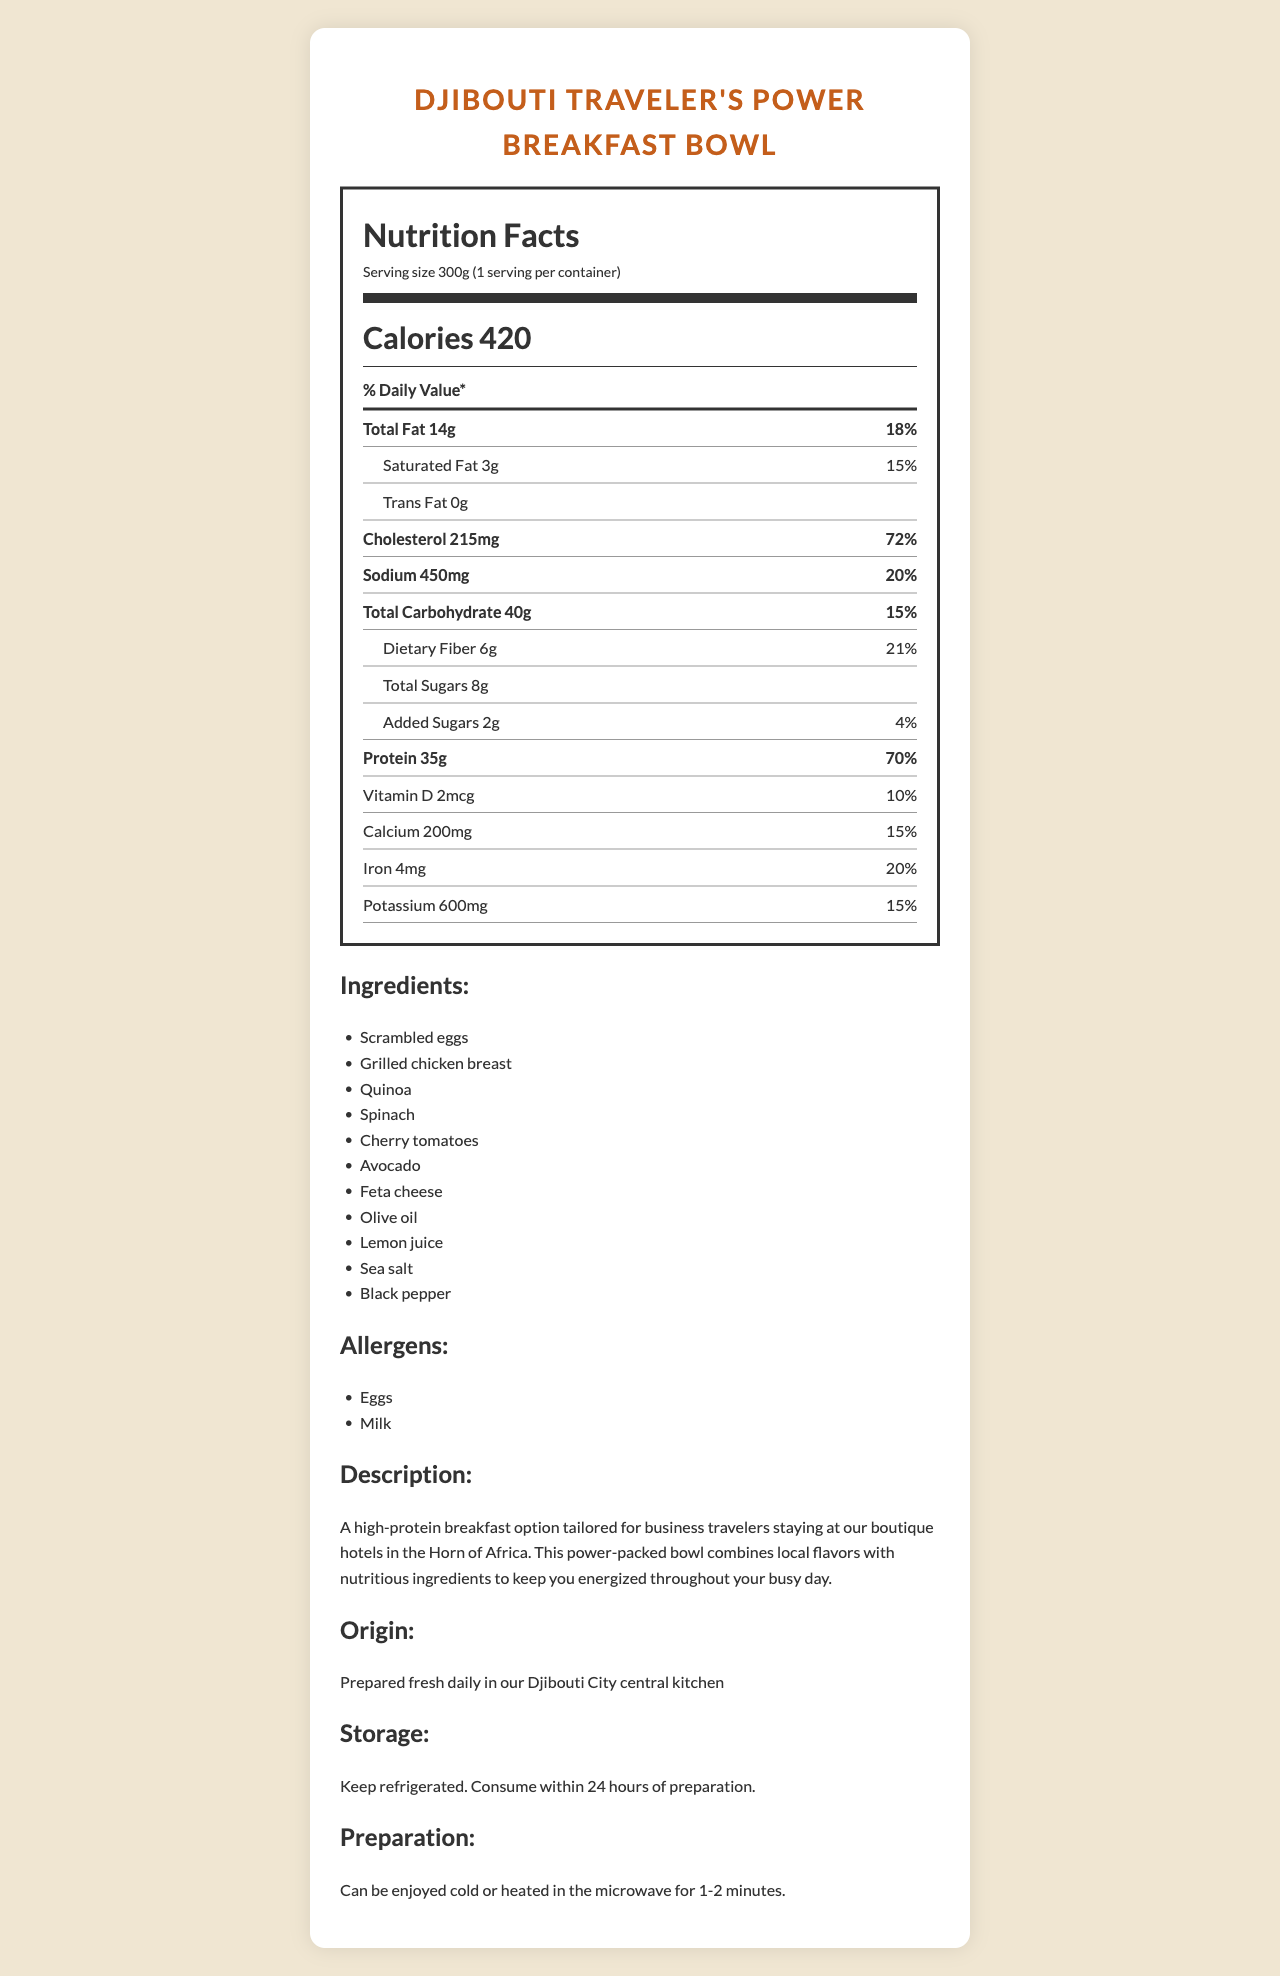what is the serving size of the Djibouti Traveler's Power Breakfast Bowl? The serving size is specified as 300g in the document.
Answer: 300g what is the total calorie count per serving? The calorie count per serving is provided as 420 calories in the document.
Answer: 420 calories how much protein is in one serving? The document states that there are 35g of protein per serving.
Answer: 35g what is the origin of the product? The origin information states that it is prepared fresh daily in their Djibouti City central kitchen.
Answer: Prepared fresh daily in our Djibouti City central kitchen what are the main ingredients? These ingredients are listed under the "Ingredients" section of the document.
Answer: Scrambled eggs, Grilled chicken breast, Quinoa, Spinach, Cherry tomatoes, Avocado, Feta cheese, Olive oil, Lemon juice, Sea salt, Black pepper what is the percentage daily value of calcium? The document specifies that the percentage daily value of calcium is 15%.
Answer: 15% how is the product stored? The storage instructions mention keeping the product refrigerated and consuming it within 24 hours of preparation.
Answer: Keep refrigerated. Consume within 24 hours of preparation. which of the following ingredients is not in the Djibouti Traveler's Power Breakfast Bowl? A. Grilled chicken breast B. Quinoa C. Brown rice Brown rice is not listed among the ingredients in the document, whereas grilled chicken breast and quinoa are listed.
Answer: C. Brown rice how many grams of dietary fiber are in one serving? The dietary fiber content per serving is mentioned as 6g in the document.
Answer: 6g what are the allergens listed for the product? The allergens listed in the document are eggs and milk.
Answer: Eggs, Milk what is the daily value percentage for protein? The document states that the daily value percentage for protein is 70%.
Answer: 70% how much added sugar does the product contain? The added sugar content is given as 2g in the document.
Answer: 2g how many calories come from fat? A. 20 B. 120 C. 126 D. 154 The total fat is 14g, and since 1 gram of fat equals 9 calories, 14g * 9 = 126 calories. Thus, the correct option is approximately B. 120.
Answer: B. 120 is there any trans fat in the product? The document states that there is 0g of trans fat.
Answer: No what is the recommended method of preparation for the Djibouti Traveler's Power Breakfast Bowl? The preparation instructions mention that the product can be enjoyed cold or heated in the microwave for 1-2 minutes.
Answer: Can be enjoyed cold or heated in the microwave for 1-2 minutes. what is the main purpose of the Djibouti Traveler's Power Breakfast Bowl? The description mentions that it is a high-protein breakfast option tailored for business travelers staying at the boutique hotels.
Answer: To provide a high-protein breakfast option tailored for business travelers staying at the boutique hotels. do the existing daily value percentages meet the Recommended Dietary Allowances (RDAs)? The document provides percentage daily values, but it does not compare them with the Recommended Dietary Allowances (RDAs) for different demographics or activity levels.
Answer: Not enough information 